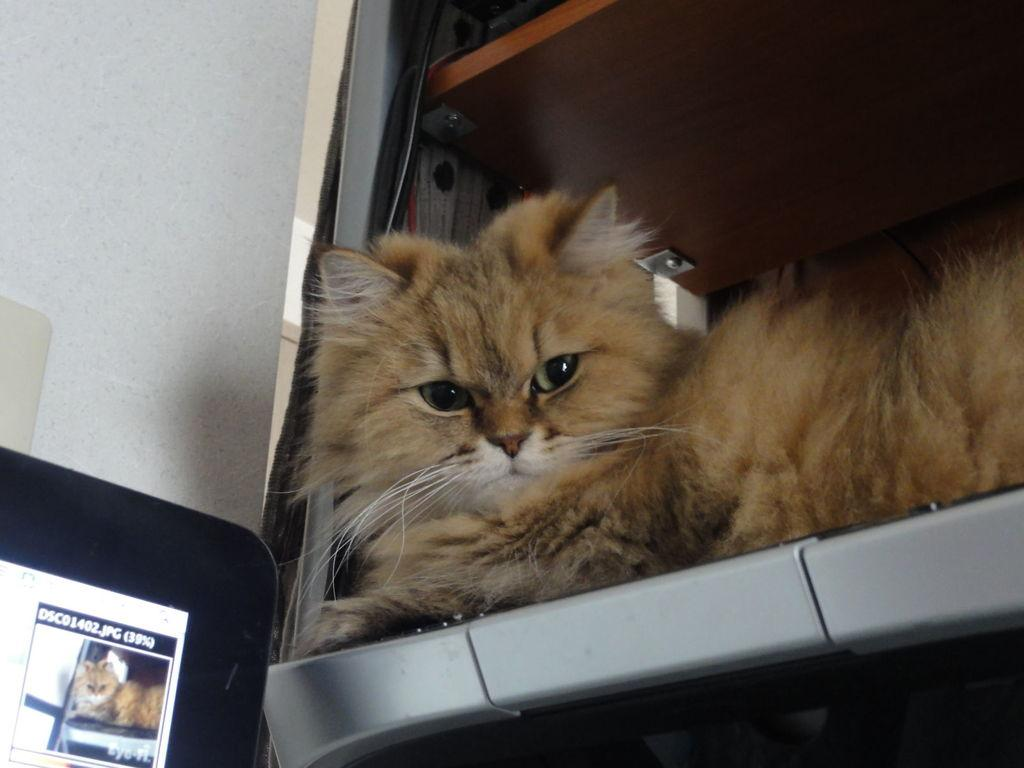What animal is lying on a shelf in the image? There is a cat lying on a shelf in the image. On which side of the image is the cat located? The cat is on the right side of the image. What electronic device is present in the image? There is a screen in the image. On which side of the image is the screen located? The screen is on the left side of the image. What can be seen in the background of the image? There is a wall visible in the background of the image. How does the car affect the family in the image? There is no car or family present in the image; it features a cat lying on a shelf and a screen on the left side. 